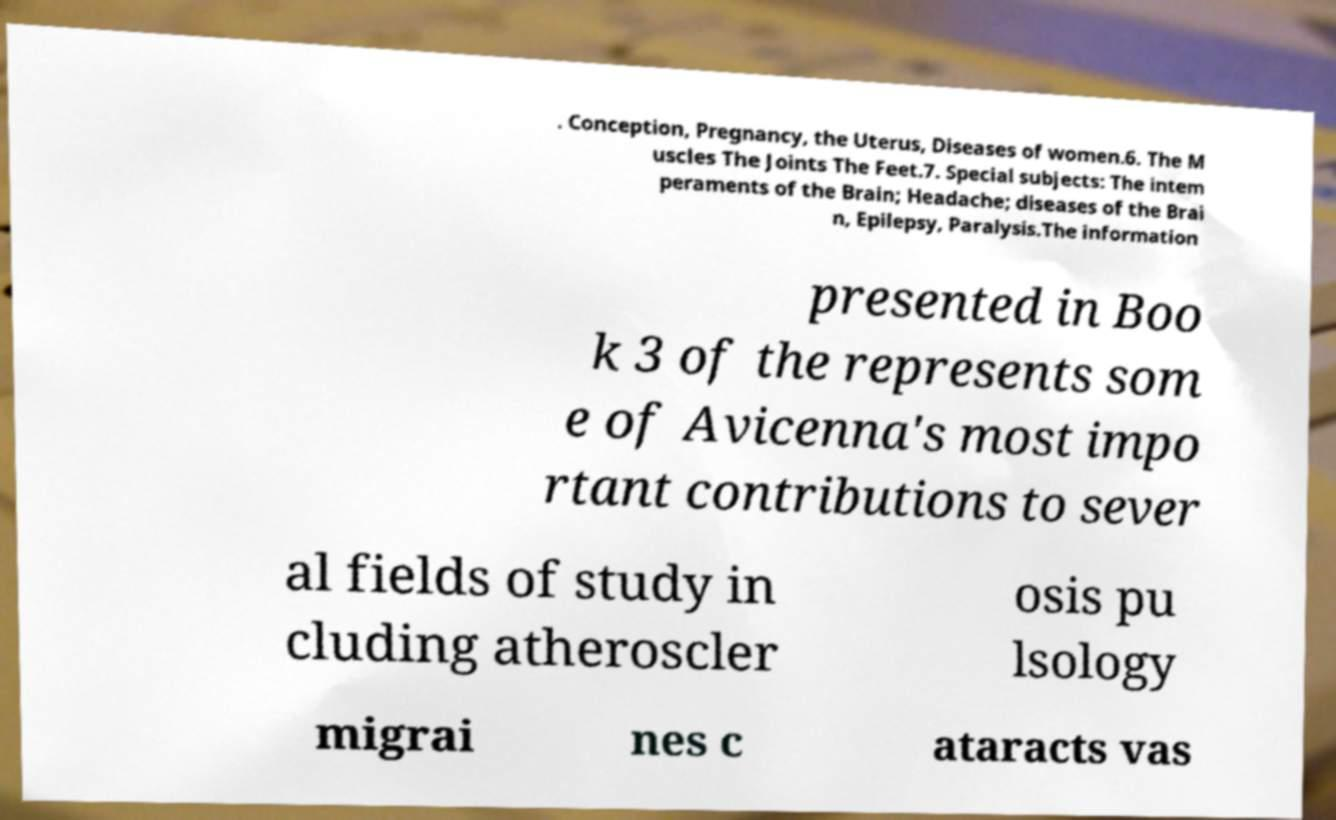For documentation purposes, I need the text within this image transcribed. Could you provide that? . Conception, Pregnancy, the Uterus, Diseases of women.6. The M uscles The Joints The Feet.7. Special subjects: The intem peraments of the Brain; Headache; diseases of the Brai n, Epilepsy, Paralysis.The information presented in Boo k 3 of the represents som e of Avicenna's most impo rtant contributions to sever al fields of study in cluding atheroscler osis pu lsology migrai nes c ataracts vas 